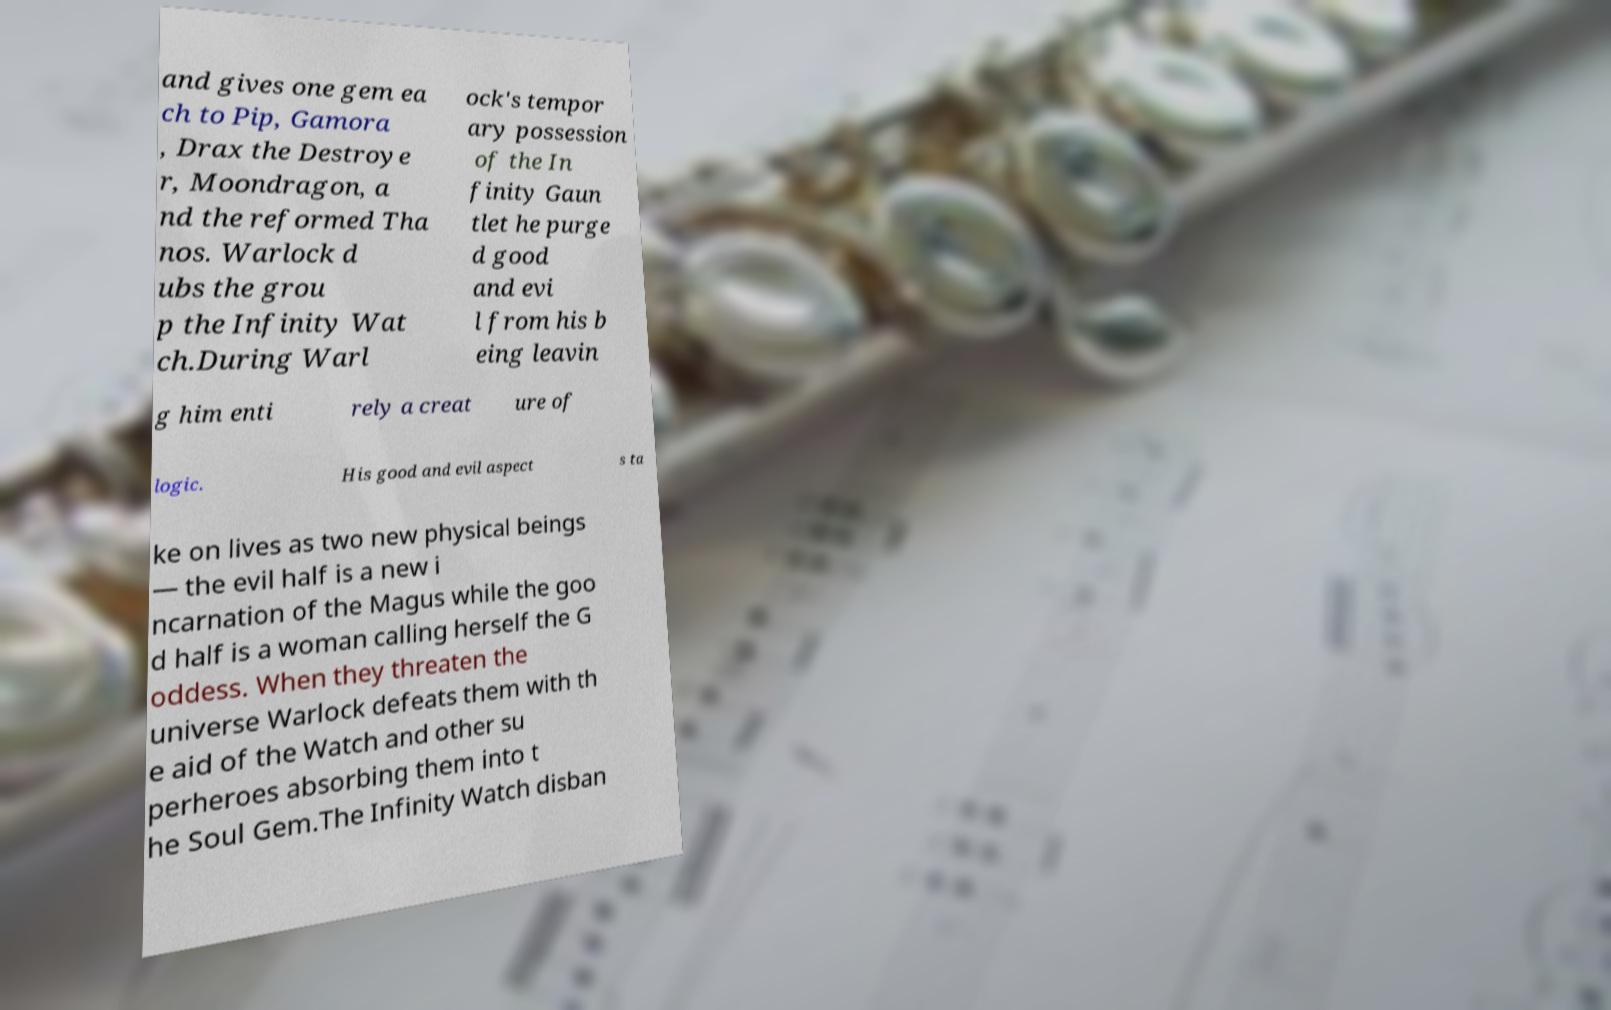There's text embedded in this image that I need extracted. Can you transcribe it verbatim? and gives one gem ea ch to Pip, Gamora , Drax the Destroye r, Moondragon, a nd the reformed Tha nos. Warlock d ubs the grou p the Infinity Wat ch.During Warl ock's tempor ary possession of the In finity Gaun tlet he purge d good and evi l from his b eing leavin g him enti rely a creat ure of logic. His good and evil aspect s ta ke on lives as two new physical beings — the evil half is a new i ncarnation of the Magus while the goo d half is a woman calling herself the G oddess. When they threaten the universe Warlock defeats them with th e aid of the Watch and other su perheroes absorbing them into t he Soul Gem.The Infinity Watch disban 